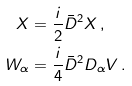<formula> <loc_0><loc_0><loc_500><loc_500>X & = \frac { i } { 2 } \bar { D } ^ { 2 } X \, , \\ W _ { \alpha } & = \frac { i } { 4 } \bar { D } ^ { 2 } D _ { \alpha } V \, .</formula> 